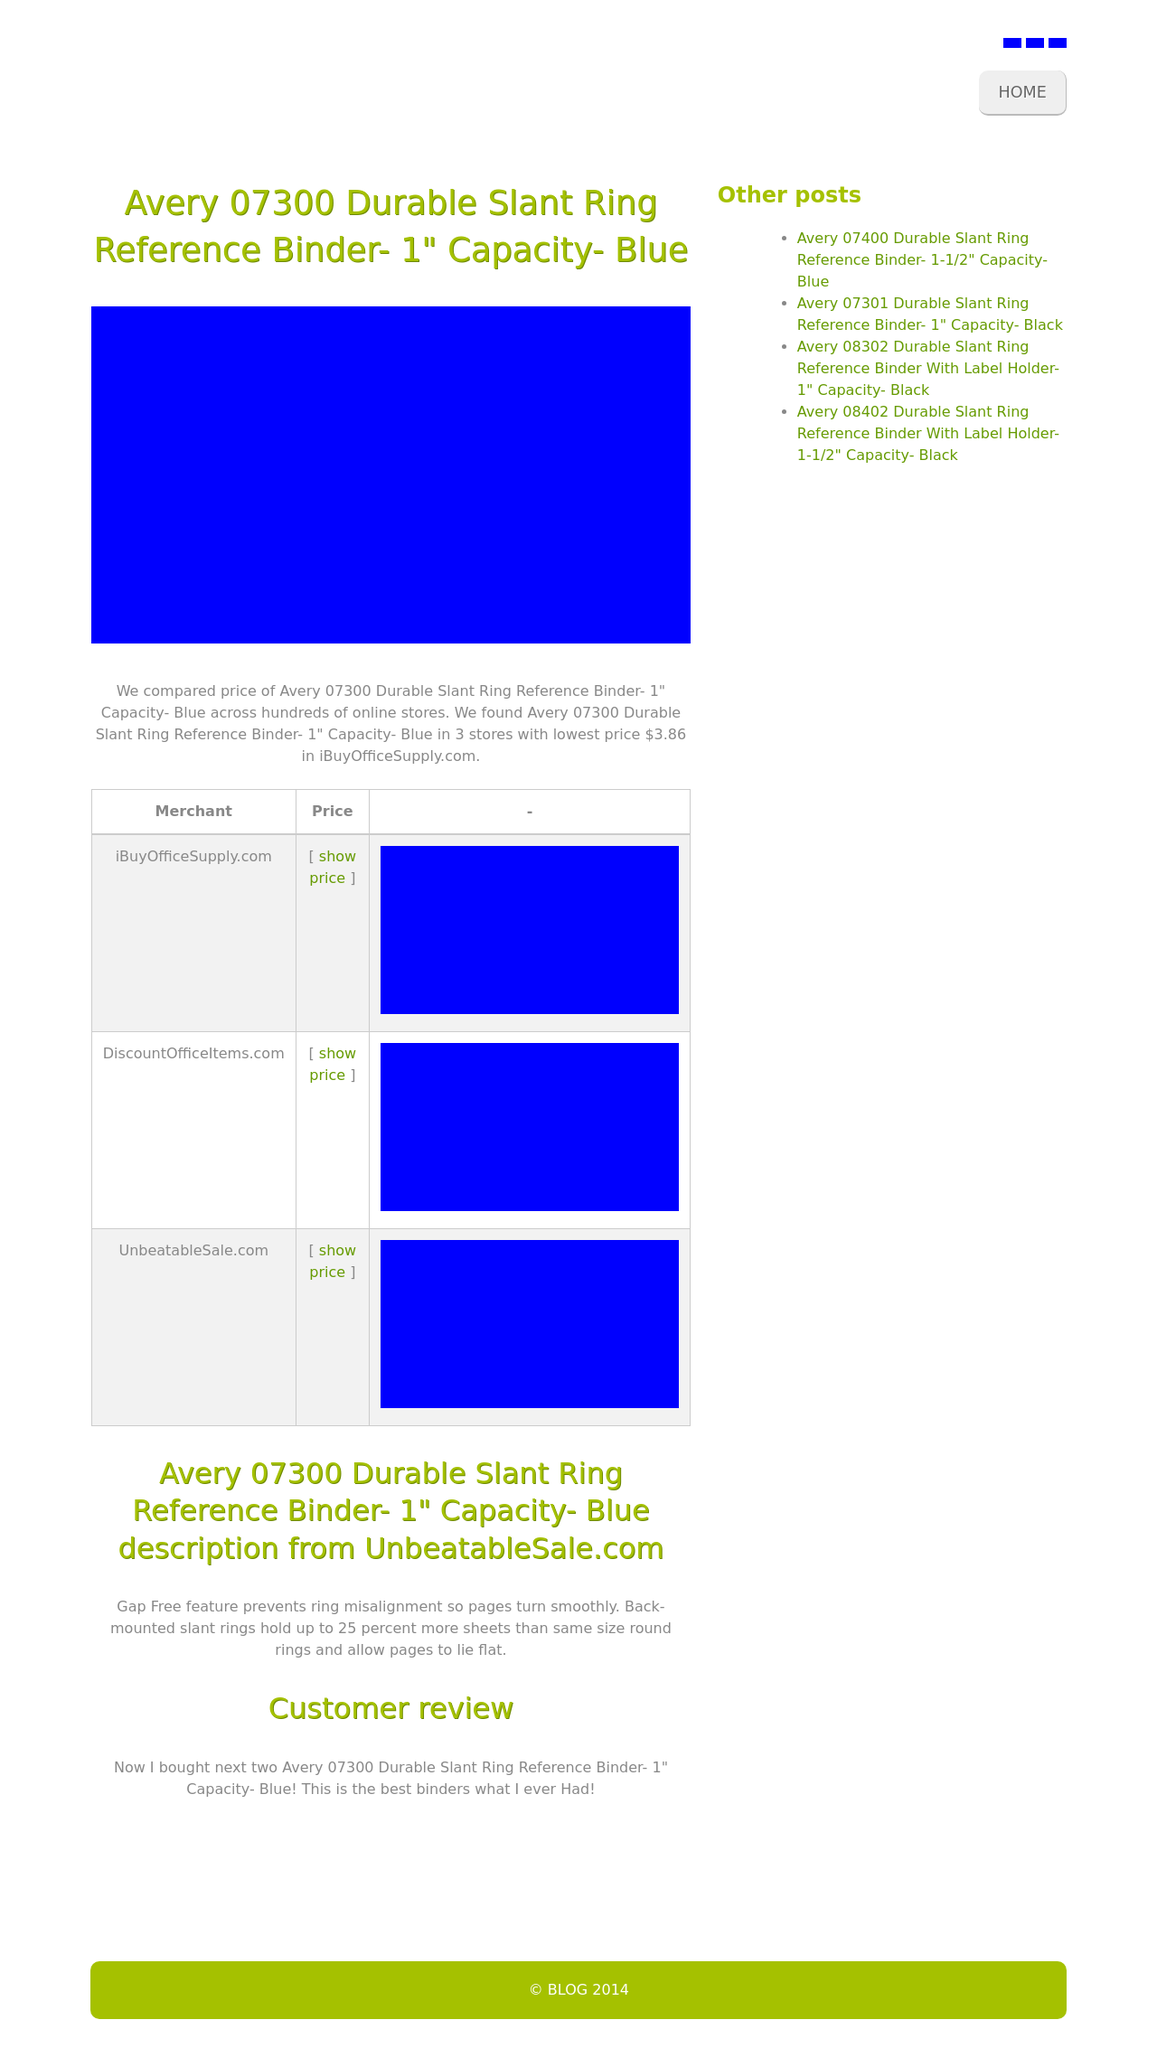What are the SEO implications of the structure used in this website's HTML? The use of clear and meaningful HTML tags like <header>, <nav>, <main>, and <footer> aids in SEO as they provide semantic meaning to the webpage, making it easier for search engines to understand the content structure. The use of <h1> tags for titles helps emphasize important text for SEO, and the list elements within <nav> facilitate search engine understanding of site navigation, potentially boosting the site's ranking for relevant queries. 